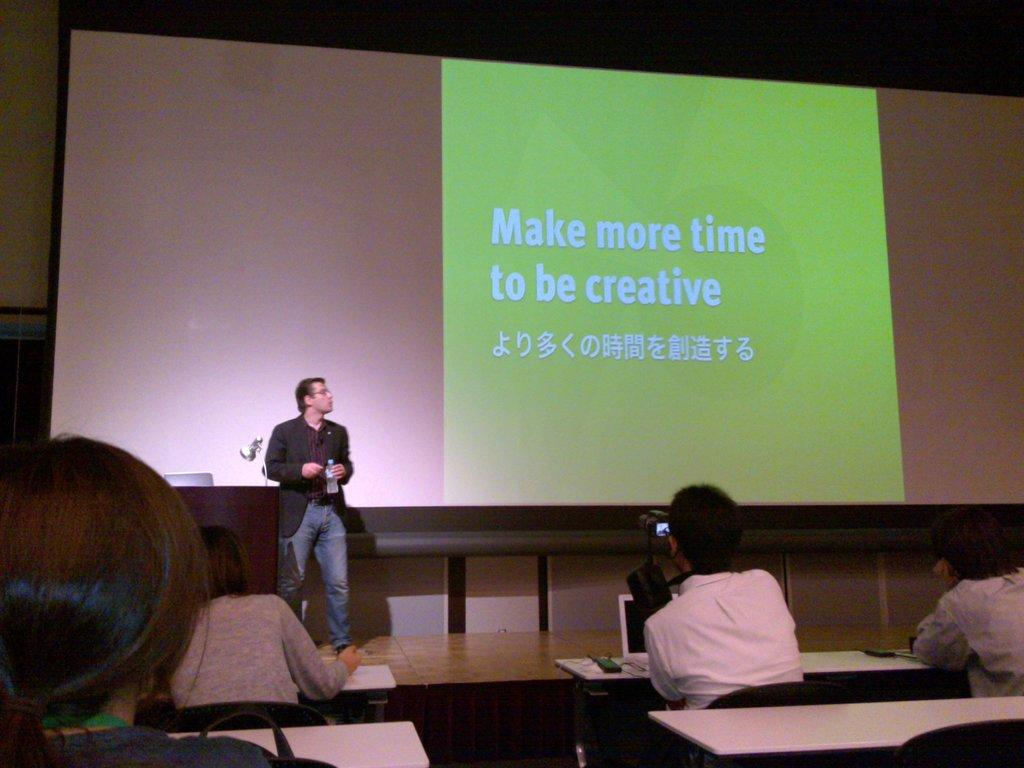Provide a one-sentence caption for the provided image. A presenter behind a screen entitled Make more time to be creative. 